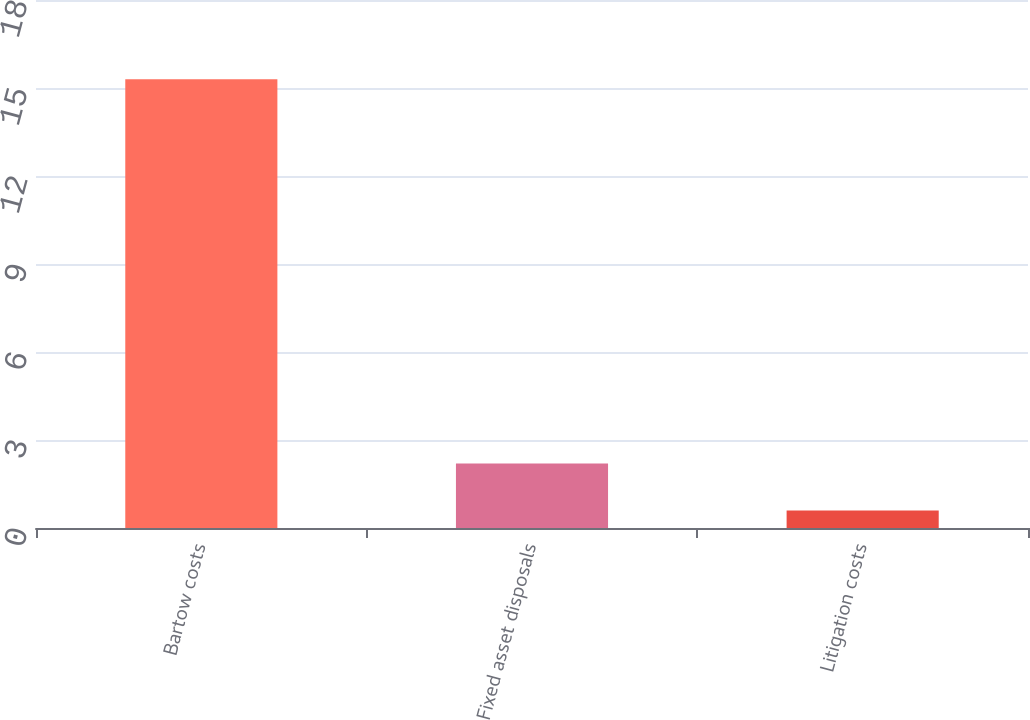<chart> <loc_0><loc_0><loc_500><loc_500><bar_chart><fcel>Bartow costs<fcel>Fixed asset disposals<fcel>Litigation costs<nl><fcel>15.3<fcel>2.2<fcel>0.6<nl></chart> 